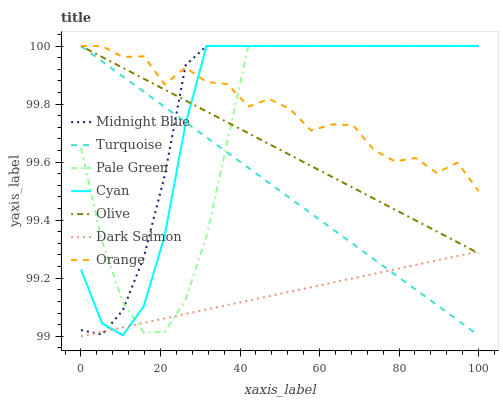Does Dark Salmon have the minimum area under the curve?
Answer yes or no. Yes. Does Midnight Blue have the maximum area under the curve?
Answer yes or no. Yes. Does Midnight Blue have the minimum area under the curve?
Answer yes or no. No. Does Dark Salmon have the maximum area under the curve?
Answer yes or no. No. Is Turquoise the smoothest?
Answer yes or no. Yes. Is Orange the roughest?
Answer yes or no. Yes. Is Midnight Blue the smoothest?
Answer yes or no. No. Is Midnight Blue the roughest?
Answer yes or no. No. Does Midnight Blue have the lowest value?
Answer yes or no. No. Does Cyan have the highest value?
Answer yes or no. Yes. Does Dark Salmon have the highest value?
Answer yes or no. No. Is Dark Salmon less than Orange?
Answer yes or no. Yes. Is Orange greater than Dark Salmon?
Answer yes or no. Yes. Does Orange intersect Cyan?
Answer yes or no. Yes. Is Orange less than Cyan?
Answer yes or no. No. Is Orange greater than Cyan?
Answer yes or no. No. Does Dark Salmon intersect Orange?
Answer yes or no. No. 